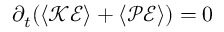Convert formula to latex. <formula><loc_0><loc_0><loc_500><loc_500>\partial _ { t } ( { \left \langle \mathcal { K E } \right \rangle } + { \left \langle \mathcal { P E } \right \rangle } ) = 0</formula> 